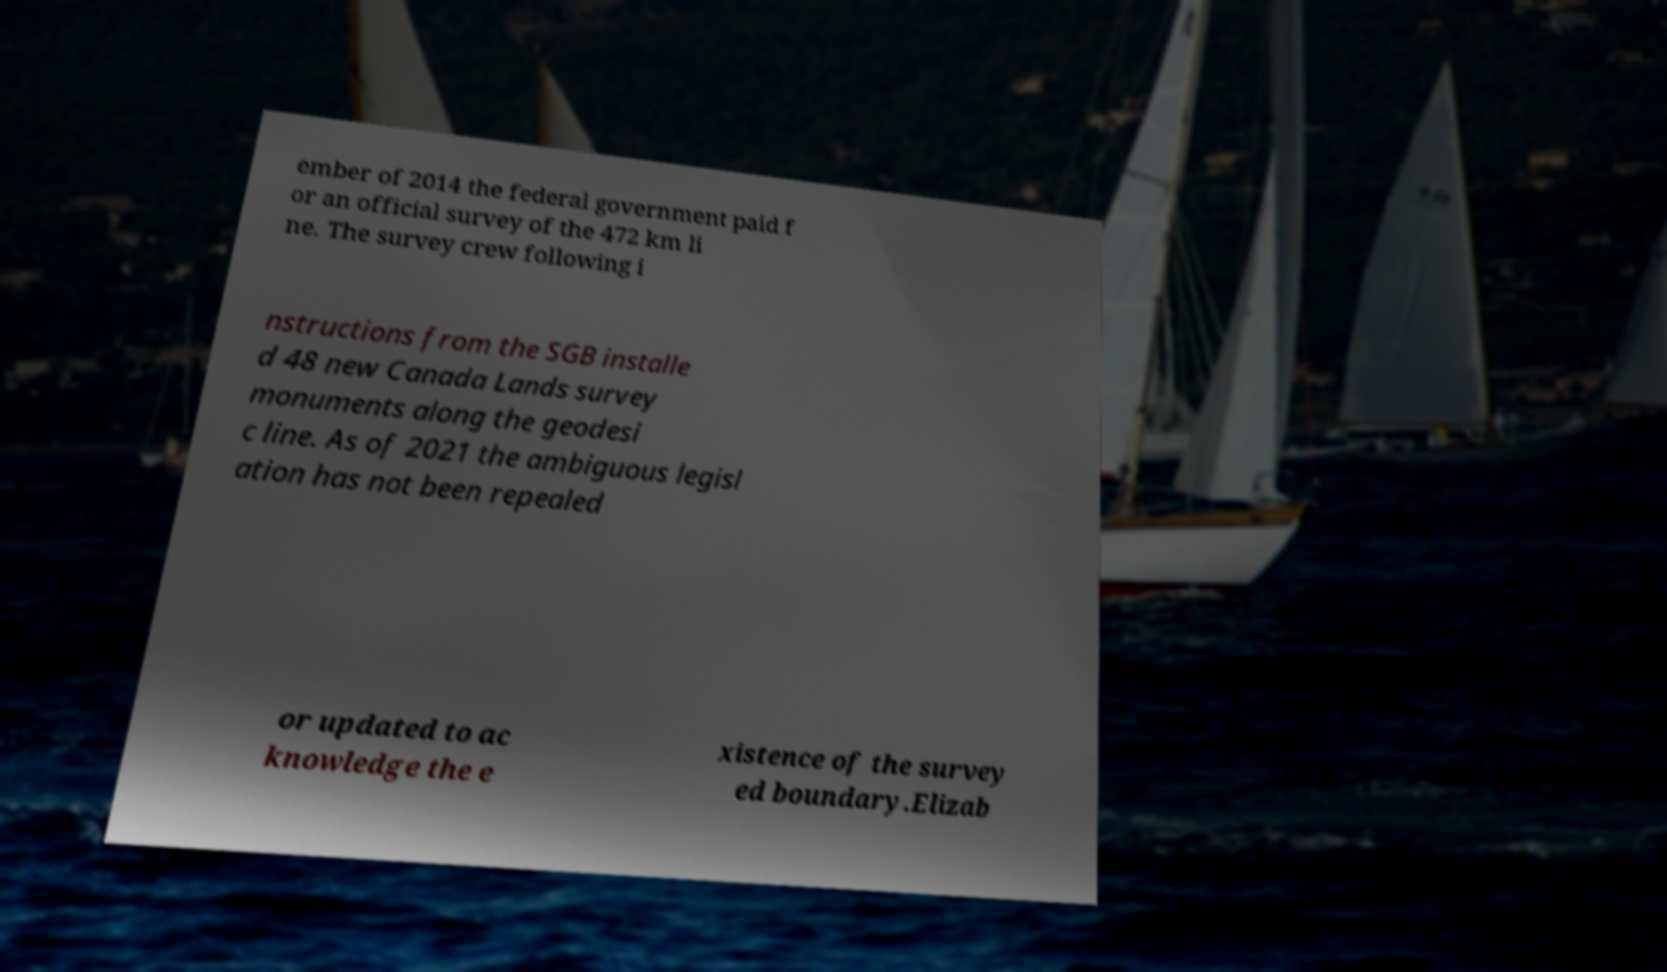Please identify and transcribe the text found in this image. ember of 2014 the federal government paid f or an official survey of the 472 km li ne. The survey crew following i nstructions from the SGB installe d 48 new Canada Lands survey monuments along the geodesi c line. As of 2021 the ambiguous legisl ation has not been repealed or updated to ac knowledge the e xistence of the survey ed boundary.Elizab 